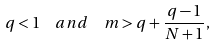Convert formula to latex. <formula><loc_0><loc_0><loc_500><loc_500>q < 1 \ \ a n d \ \ m > q + \frac { q - 1 } { N + 1 } ,</formula> 